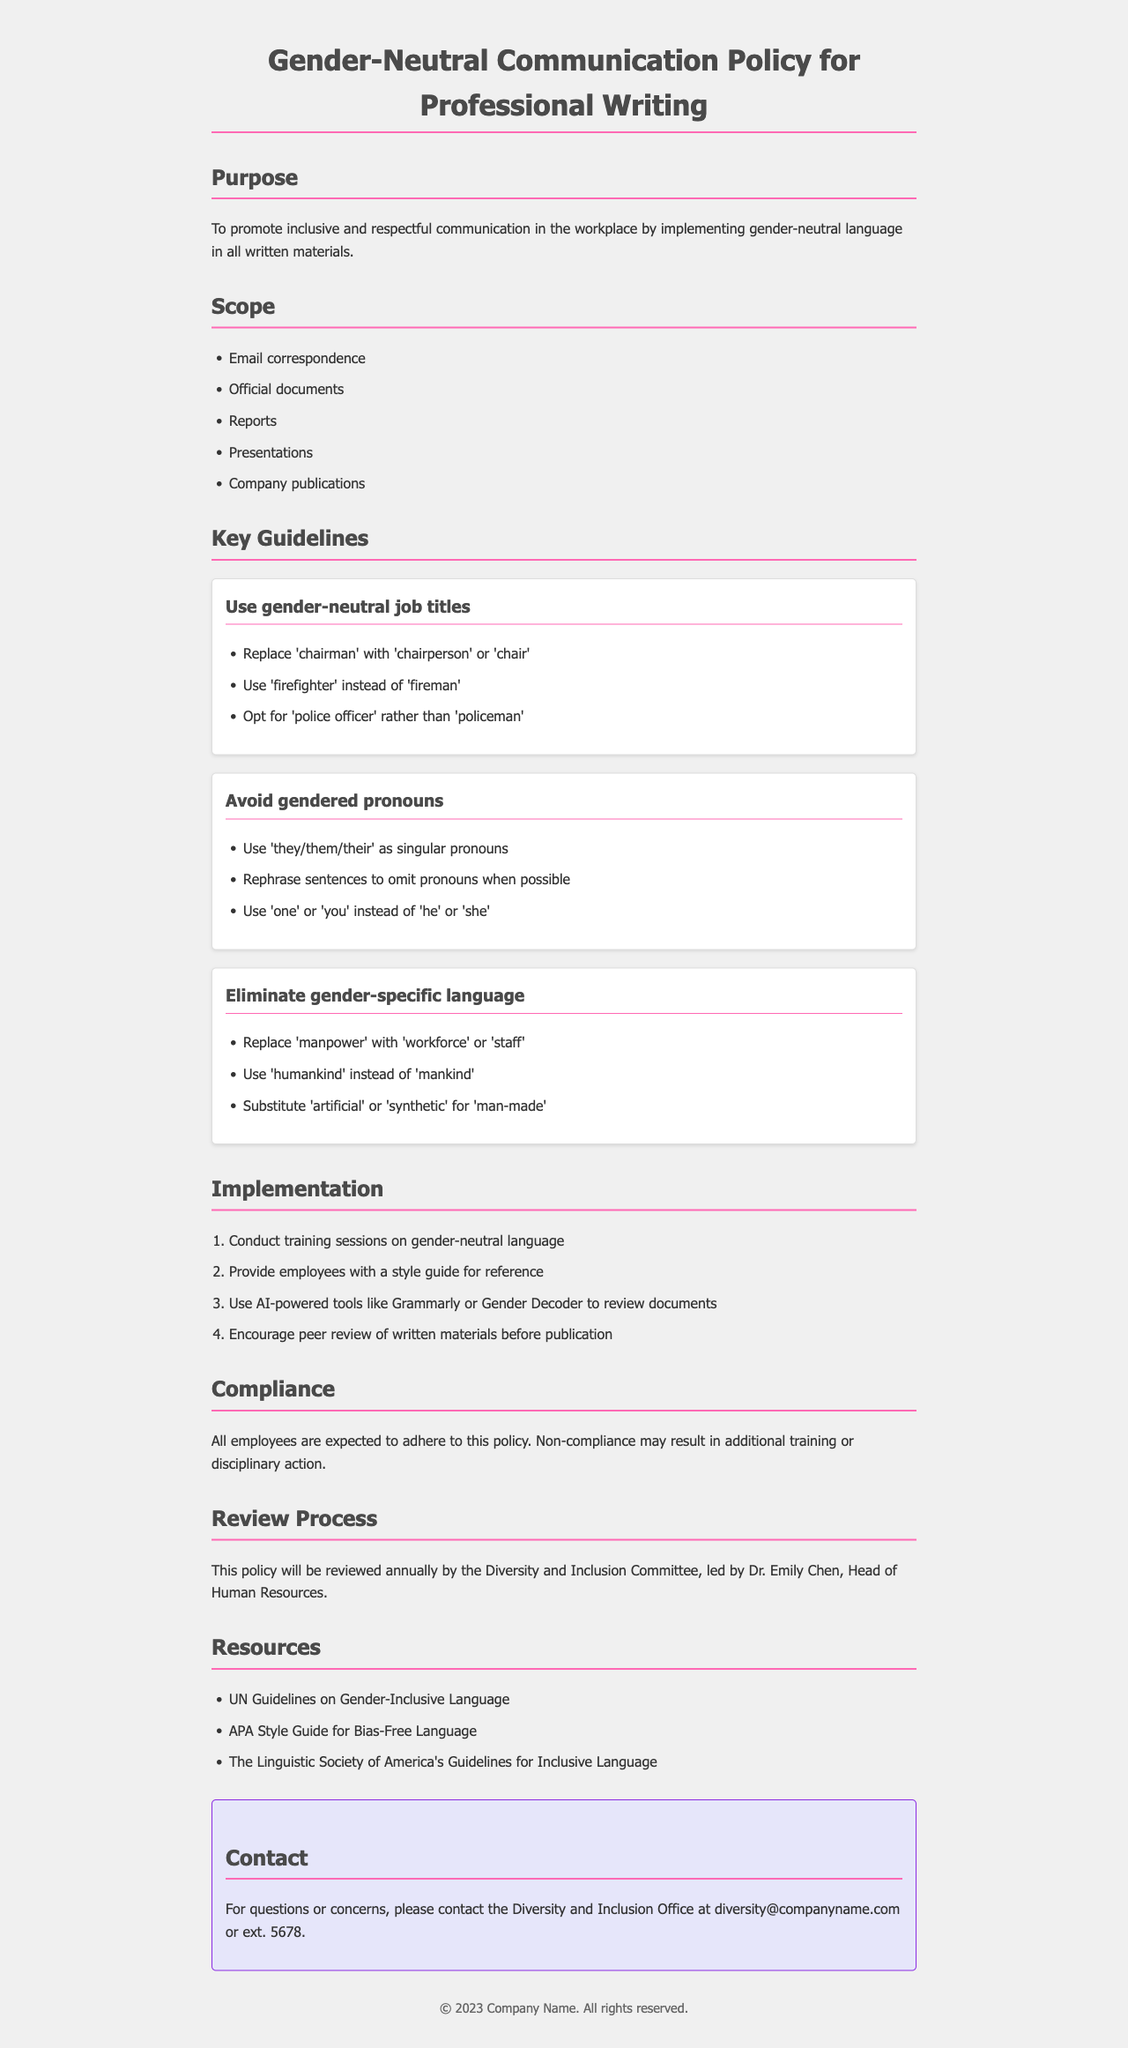What is the purpose of this policy? The purpose is to promote inclusive and respectful communication in the workplace by implementing gender-neutral language in all written materials.
Answer: To promote inclusive and respectful communication What type of documents does the scope cover? The scope of the policy includes types of documents such as email correspondence, official documents, reports, presentations, and company publications.
Answer: Email correspondence, Official documents, Reports, Presentations, Company publications Which singular pronouns are suggested to use? The policy recommends using singular pronouns 'they/them/their' and to rephrase sentences to omit pronouns when possible.
Answer: They/them/their Who is responsible for reviewing the policy annually? The Diversity and Inclusion Committee, led by Dr. Emily Chen, is responsible for reviewing the policy annually.
Answer: Dr. Emily Chen What should employees expect for non-compliance? Non-compliance may result in additional training or disciplinary action for employees.
Answer: Additional training or disciplinary action How many key guidelines are provided in the document? There are three key guidelines provided in the document regarding gender-neutral communication.
Answer: Three What tools are suggested for reviewing documents? The document suggests using AI-powered tools such as Grammarly or Gender Decoder for reviewing documents.
Answer: Grammarly or Gender Decoder What is the contact email for the Diversity and Inclusion Office? The contact email provided for questions or concerns is diversity@companyname.com.
Answer: diversity@companyname.com What resource is mentioned for gender-inclusive language? The document mentions the UN Guidelines on Gender-Inclusive Language as one of the resources.
Answer: UN Guidelines on Gender-Inclusive Language 